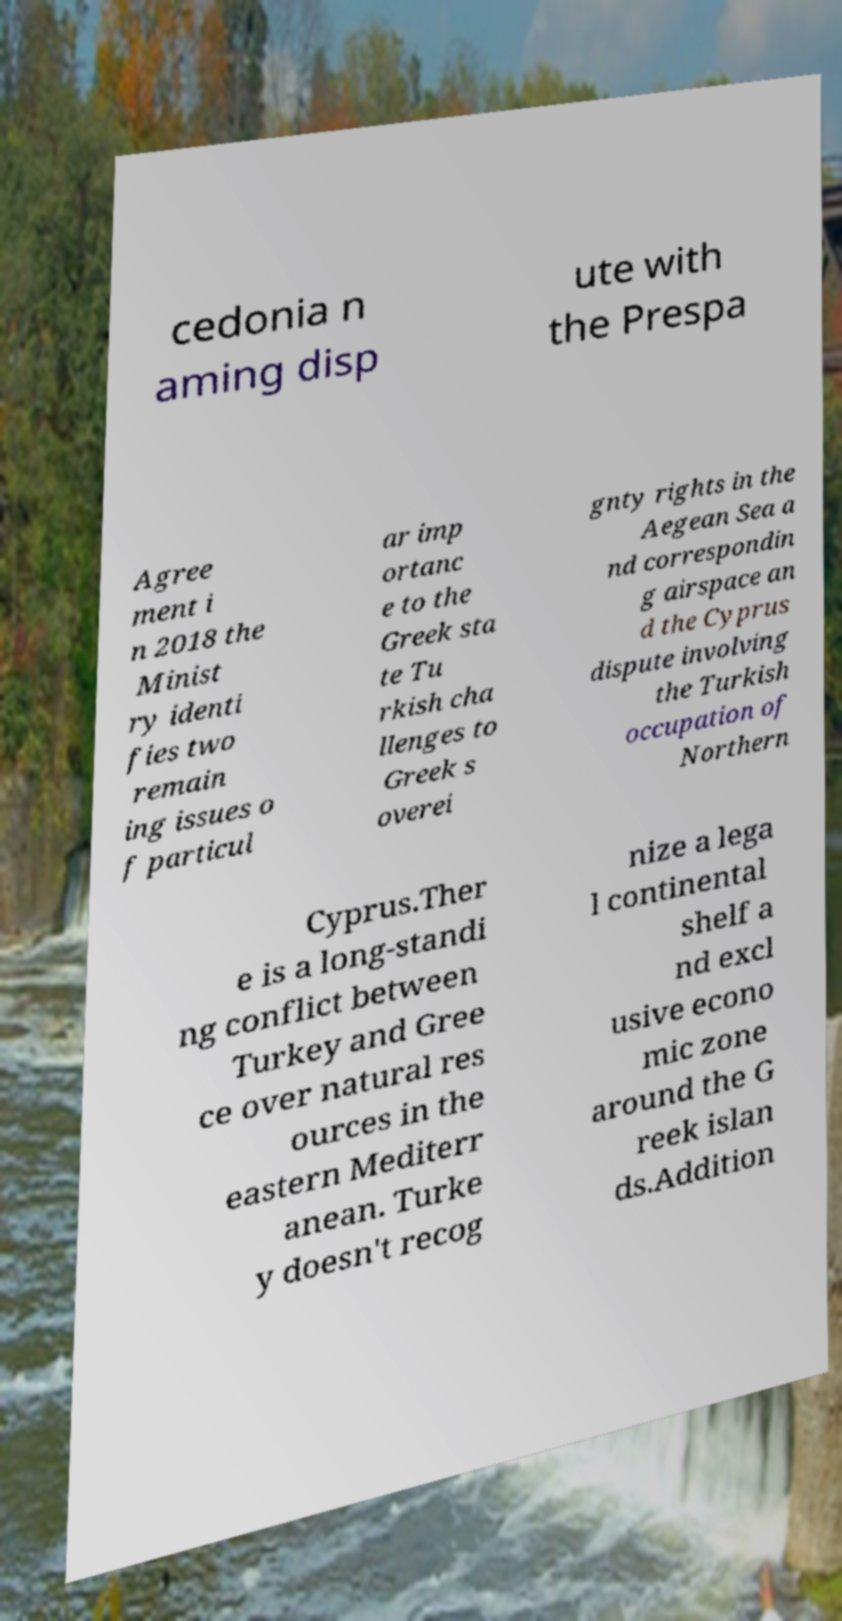Please read and relay the text visible in this image. What does it say? cedonia n aming disp ute with the Prespa Agree ment i n 2018 the Minist ry identi fies two remain ing issues o f particul ar imp ortanc e to the Greek sta te Tu rkish cha llenges to Greek s overei gnty rights in the Aegean Sea a nd correspondin g airspace an d the Cyprus dispute involving the Turkish occupation of Northern Cyprus.Ther e is a long-standi ng conflict between Turkey and Gree ce over natural res ources in the eastern Mediterr anean. Turke y doesn't recog nize a lega l continental shelf a nd excl usive econo mic zone around the G reek islan ds.Addition 